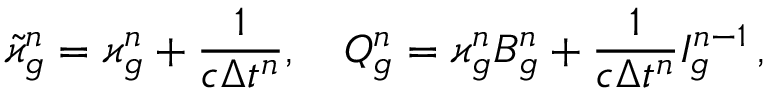<formula> <loc_0><loc_0><loc_500><loc_500>\tilde { \varkappa } _ { g } ^ { n } = \varkappa _ { g } ^ { n } + \frac { 1 } { c \Delta t ^ { n } } , \quad Q _ { g } ^ { n } = \varkappa _ { g } ^ { n } B _ { g } ^ { n } + \frac { 1 } { c \Delta t ^ { n } } I _ { g } ^ { n - 1 } \, ,</formula> 